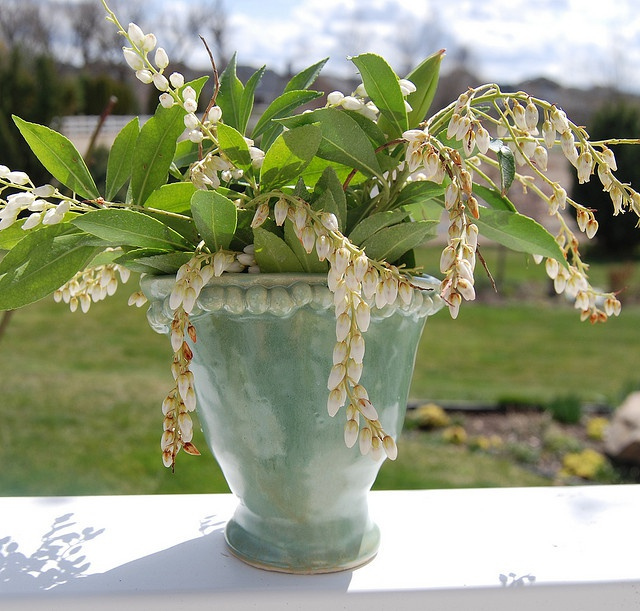Describe the objects in this image and their specific colors. I can see potted plant in darkgray, darkgreen, gray, and olive tones and vase in darkgray, gray, and olive tones in this image. 